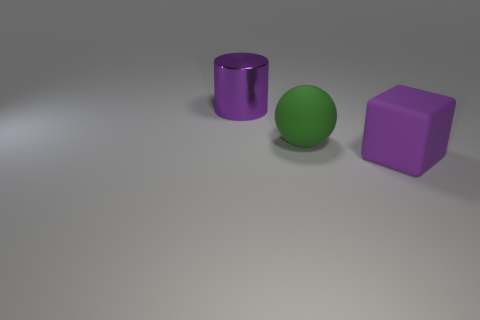Add 2 large yellow balls. How many objects exist? 5 Add 1 matte things. How many matte things are left? 3 Add 1 large shiny cylinders. How many large shiny cylinders exist? 2 Subtract 1 green spheres. How many objects are left? 2 Subtract all cubes. How many objects are left? 2 Subtract all green cylinders. How many blue cubes are left? 0 Subtract all large metallic cylinders. Subtract all metallic cylinders. How many objects are left? 1 